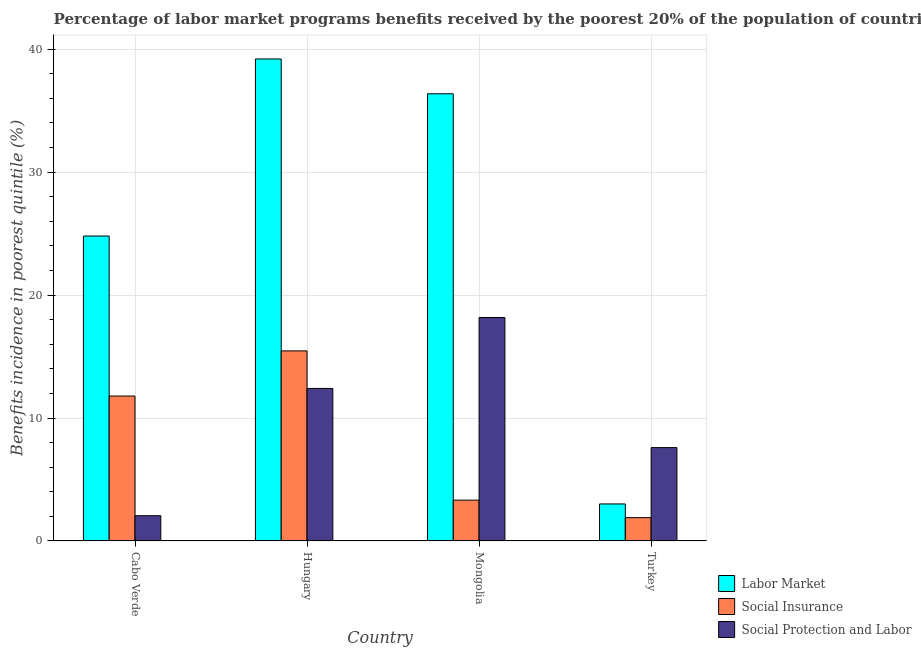Are the number of bars on each tick of the X-axis equal?
Offer a terse response. Yes. How many bars are there on the 4th tick from the right?
Your answer should be compact. 3. In how many cases, is the number of bars for a given country not equal to the number of legend labels?
Make the answer very short. 0. What is the percentage of benefits received due to labor market programs in Cabo Verde?
Provide a short and direct response. 24.8. Across all countries, what is the maximum percentage of benefits received due to social protection programs?
Your answer should be very brief. 18.18. Across all countries, what is the minimum percentage of benefits received due to social insurance programs?
Ensure brevity in your answer.  1.89. In which country was the percentage of benefits received due to social insurance programs maximum?
Make the answer very short. Hungary. In which country was the percentage of benefits received due to social protection programs minimum?
Provide a short and direct response. Cabo Verde. What is the total percentage of benefits received due to labor market programs in the graph?
Your answer should be compact. 103.39. What is the difference between the percentage of benefits received due to social protection programs in Hungary and that in Turkey?
Provide a short and direct response. 4.81. What is the difference between the percentage of benefits received due to social protection programs in Cabo Verde and the percentage of benefits received due to social insurance programs in Mongolia?
Your answer should be compact. -1.27. What is the average percentage of benefits received due to labor market programs per country?
Your answer should be very brief. 25.85. What is the difference between the percentage of benefits received due to social insurance programs and percentage of benefits received due to labor market programs in Hungary?
Offer a very short reply. -23.75. In how many countries, is the percentage of benefits received due to social insurance programs greater than 2 %?
Provide a short and direct response. 3. What is the ratio of the percentage of benefits received due to social insurance programs in Mongolia to that in Turkey?
Ensure brevity in your answer.  1.75. Is the percentage of benefits received due to labor market programs in Hungary less than that in Turkey?
Make the answer very short. No. What is the difference between the highest and the second highest percentage of benefits received due to social protection programs?
Provide a succinct answer. 5.77. What is the difference between the highest and the lowest percentage of benefits received due to social insurance programs?
Offer a very short reply. 13.57. In how many countries, is the percentage of benefits received due to social protection programs greater than the average percentage of benefits received due to social protection programs taken over all countries?
Your answer should be very brief. 2. Is the sum of the percentage of benefits received due to labor market programs in Cabo Verde and Mongolia greater than the maximum percentage of benefits received due to social protection programs across all countries?
Keep it short and to the point. Yes. What does the 3rd bar from the left in Cabo Verde represents?
Provide a succinct answer. Social Protection and Labor. What does the 3rd bar from the right in Mongolia represents?
Offer a very short reply. Labor Market. Is it the case that in every country, the sum of the percentage of benefits received due to labor market programs and percentage of benefits received due to social insurance programs is greater than the percentage of benefits received due to social protection programs?
Provide a short and direct response. No. How many countries are there in the graph?
Your answer should be compact. 4. Are the values on the major ticks of Y-axis written in scientific E-notation?
Ensure brevity in your answer.  No. Where does the legend appear in the graph?
Offer a very short reply. Bottom right. What is the title of the graph?
Provide a short and direct response. Percentage of labor market programs benefits received by the poorest 20% of the population of countries. Does "Transport services" appear as one of the legend labels in the graph?
Your response must be concise. No. What is the label or title of the Y-axis?
Keep it short and to the point. Benefits incidence in poorest quintile (%). What is the Benefits incidence in poorest quintile (%) of Labor Market in Cabo Verde?
Offer a terse response. 24.8. What is the Benefits incidence in poorest quintile (%) in Social Insurance in Cabo Verde?
Make the answer very short. 11.79. What is the Benefits incidence in poorest quintile (%) in Social Protection and Labor in Cabo Verde?
Give a very brief answer. 2.05. What is the Benefits incidence in poorest quintile (%) of Labor Market in Hungary?
Keep it short and to the point. 39.21. What is the Benefits incidence in poorest quintile (%) of Social Insurance in Hungary?
Make the answer very short. 15.46. What is the Benefits incidence in poorest quintile (%) in Social Protection and Labor in Hungary?
Provide a short and direct response. 12.41. What is the Benefits incidence in poorest quintile (%) in Labor Market in Mongolia?
Ensure brevity in your answer.  36.38. What is the Benefits incidence in poorest quintile (%) of Social Insurance in Mongolia?
Offer a very short reply. 3.32. What is the Benefits incidence in poorest quintile (%) of Social Protection and Labor in Mongolia?
Your response must be concise. 18.18. What is the Benefits incidence in poorest quintile (%) in Labor Market in Turkey?
Provide a succinct answer. 3.01. What is the Benefits incidence in poorest quintile (%) of Social Insurance in Turkey?
Your response must be concise. 1.89. What is the Benefits incidence in poorest quintile (%) of Social Protection and Labor in Turkey?
Ensure brevity in your answer.  7.59. Across all countries, what is the maximum Benefits incidence in poorest quintile (%) in Labor Market?
Your answer should be compact. 39.21. Across all countries, what is the maximum Benefits incidence in poorest quintile (%) in Social Insurance?
Your response must be concise. 15.46. Across all countries, what is the maximum Benefits incidence in poorest quintile (%) in Social Protection and Labor?
Provide a short and direct response. 18.18. Across all countries, what is the minimum Benefits incidence in poorest quintile (%) in Labor Market?
Make the answer very short. 3.01. Across all countries, what is the minimum Benefits incidence in poorest quintile (%) of Social Insurance?
Provide a succinct answer. 1.89. Across all countries, what is the minimum Benefits incidence in poorest quintile (%) of Social Protection and Labor?
Keep it short and to the point. 2.05. What is the total Benefits incidence in poorest quintile (%) in Labor Market in the graph?
Provide a succinct answer. 103.39. What is the total Benefits incidence in poorest quintile (%) in Social Insurance in the graph?
Your response must be concise. 32.46. What is the total Benefits incidence in poorest quintile (%) of Social Protection and Labor in the graph?
Provide a short and direct response. 40.23. What is the difference between the Benefits incidence in poorest quintile (%) in Labor Market in Cabo Verde and that in Hungary?
Offer a terse response. -14.4. What is the difference between the Benefits incidence in poorest quintile (%) in Social Insurance in Cabo Verde and that in Hungary?
Your response must be concise. -3.67. What is the difference between the Benefits incidence in poorest quintile (%) in Social Protection and Labor in Cabo Verde and that in Hungary?
Your answer should be very brief. -10.35. What is the difference between the Benefits incidence in poorest quintile (%) in Labor Market in Cabo Verde and that in Mongolia?
Your response must be concise. -11.57. What is the difference between the Benefits incidence in poorest quintile (%) of Social Insurance in Cabo Verde and that in Mongolia?
Your answer should be very brief. 8.47. What is the difference between the Benefits incidence in poorest quintile (%) in Social Protection and Labor in Cabo Verde and that in Mongolia?
Your answer should be very brief. -16.12. What is the difference between the Benefits incidence in poorest quintile (%) of Labor Market in Cabo Verde and that in Turkey?
Your answer should be very brief. 21.79. What is the difference between the Benefits incidence in poorest quintile (%) in Social Insurance in Cabo Verde and that in Turkey?
Your answer should be very brief. 9.89. What is the difference between the Benefits incidence in poorest quintile (%) of Social Protection and Labor in Cabo Verde and that in Turkey?
Offer a terse response. -5.54. What is the difference between the Benefits incidence in poorest quintile (%) of Labor Market in Hungary and that in Mongolia?
Provide a succinct answer. 2.83. What is the difference between the Benefits incidence in poorest quintile (%) in Social Insurance in Hungary and that in Mongolia?
Provide a short and direct response. 12.14. What is the difference between the Benefits incidence in poorest quintile (%) of Social Protection and Labor in Hungary and that in Mongolia?
Your answer should be very brief. -5.77. What is the difference between the Benefits incidence in poorest quintile (%) of Labor Market in Hungary and that in Turkey?
Your answer should be compact. 36.2. What is the difference between the Benefits incidence in poorest quintile (%) in Social Insurance in Hungary and that in Turkey?
Your answer should be compact. 13.57. What is the difference between the Benefits incidence in poorest quintile (%) of Social Protection and Labor in Hungary and that in Turkey?
Offer a terse response. 4.81. What is the difference between the Benefits incidence in poorest quintile (%) of Labor Market in Mongolia and that in Turkey?
Keep it short and to the point. 33.37. What is the difference between the Benefits incidence in poorest quintile (%) in Social Insurance in Mongolia and that in Turkey?
Make the answer very short. 1.42. What is the difference between the Benefits incidence in poorest quintile (%) of Social Protection and Labor in Mongolia and that in Turkey?
Your answer should be very brief. 10.58. What is the difference between the Benefits incidence in poorest quintile (%) of Labor Market in Cabo Verde and the Benefits incidence in poorest quintile (%) of Social Insurance in Hungary?
Give a very brief answer. 9.34. What is the difference between the Benefits incidence in poorest quintile (%) of Labor Market in Cabo Verde and the Benefits incidence in poorest quintile (%) of Social Protection and Labor in Hungary?
Make the answer very short. 12.4. What is the difference between the Benefits incidence in poorest quintile (%) in Social Insurance in Cabo Verde and the Benefits incidence in poorest quintile (%) in Social Protection and Labor in Hungary?
Keep it short and to the point. -0.62. What is the difference between the Benefits incidence in poorest quintile (%) of Labor Market in Cabo Verde and the Benefits incidence in poorest quintile (%) of Social Insurance in Mongolia?
Ensure brevity in your answer.  21.48. What is the difference between the Benefits incidence in poorest quintile (%) in Labor Market in Cabo Verde and the Benefits incidence in poorest quintile (%) in Social Protection and Labor in Mongolia?
Ensure brevity in your answer.  6.63. What is the difference between the Benefits incidence in poorest quintile (%) in Social Insurance in Cabo Verde and the Benefits incidence in poorest quintile (%) in Social Protection and Labor in Mongolia?
Make the answer very short. -6.39. What is the difference between the Benefits incidence in poorest quintile (%) in Labor Market in Cabo Verde and the Benefits incidence in poorest quintile (%) in Social Insurance in Turkey?
Make the answer very short. 22.91. What is the difference between the Benefits incidence in poorest quintile (%) in Labor Market in Cabo Verde and the Benefits incidence in poorest quintile (%) in Social Protection and Labor in Turkey?
Give a very brief answer. 17.21. What is the difference between the Benefits incidence in poorest quintile (%) in Social Insurance in Cabo Verde and the Benefits incidence in poorest quintile (%) in Social Protection and Labor in Turkey?
Offer a terse response. 4.2. What is the difference between the Benefits incidence in poorest quintile (%) of Labor Market in Hungary and the Benefits incidence in poorest quintile (%) of Social Insurance in Mongolia?
Make the answer very short. 35.89. What is the difference between the Benefits incidence in poorest quintile (%) in Labor Market in Hungary and the Benefits incidence in poorest quintile (%) in Social Protection and Labor in Mongolia?
Offer a very short reply. 21.03. What is the difference between the Benefits incidence in poorest quintile (%) of Social Insurance in Hungary and the Benefits incidence in poorest quintile (%) of Social Protection and Labor in Mongolia?
Give a very brief answer. -2.72. What is the difference between the Benefits incidence in poorest quintile (%) in Labor Market in Hungary and the Benefits incidence in poorest quintile (%) in Social Insurance in Turkey?
Keep it short and to the point. 37.31. What is the difference between the Benefits incidence in poorest quintile (%) in Labor Market in Hungary and the Benefits incidence in poorest quintile (%) in Social Protection and Labor in Turkey?
Your answer should be compact. 31.62. What is the difference between the Benefits incidence in poorest quintile (%) in Social Insurance in Hungary and the Benefits incidence in poorest quintile (%) in Social Protection and Labor in Turkey?
Ensure brevity in your answer.  7.87. What is the difference between the Benefits incidence in poorest quintile (%) in Labor Market in Mongolia and the Benefits incidence in poorest quintile (%) in Social Insurance in Turkey?
Keep it short and to the point. 34.48. What is the difference between the Benefits incidence in poorest quintile (%) of Labor Market in Mongolia and the Benefits incidence in poorest quintile (%) of Social Protection and Labor in Turkey?
Your answer should be very brief. 28.78. What is the difference between the Benefits incidence in poorest quintile (%) in Social Insurance in Mongolia and the Benefits incidence in poorest quintile (%) in Social Protection and Labor in Turkey?
Offer a terse response. -4.27. What is the average Benefits incidence in poorest quintile (%) in Labor Market per country?
Provide a succinct answer. 25.85. What is the average Benefits incidence in poorest quintile (%) of Social Insurance per country?
Offer a very short reply. 8.12. What is the average Benefits incidence in poorest quintile (%) in Social Protection and Labor per country?
Offer a very short reply. 10.06. What is the difference between the Benefits incidence in poorest quintile (%) of Labor Market and Benefits incidence in poorest quintile (%) of Social Insurance in Cabo Verde?
Offer a very short reply. 13.02. What is the difference between the Benefits incidence in poorest quintile (%) in Labor Market and Benefits incidence in poorest quintile (%) in Social Protection and Labor in Cabo Verde?
Keep it short and to the point. 22.75. What is the difference between the Benefits incidence in poorest quintile (%) in Social Insurance and Benefits incidence in poorest quintile (%) in Social Protection and Labor in Cabo Verde?
Provide a short and direct response. 9.73. What is the difference between the Benefits incidence in poorest quintile (%) in Labor Market and Benefits incidence in poorest quintile (%) in Social Insurance in Hungary?
Your response must be concise. 23.75. What is the difference between the Benefits incidence in poorest quintile (%) of Labor Market and Benefits incidence in poorest quintile (%) of Social Protection and Labor in Hungary?
Your response must be concise. 26.8. What is the difference between the Benefits incidence in poorest quintile (%) in Social Insurance and Benefits incidence in poorest quintile (%) in Social Protection and Labor in Hungary?
Give a very brief answer. 3.05. What is the difference between the Benefits incidence in poorest quintile (%) of Labor Market and Benefits incidence in poorest quintile (%) of Social Insurance in Mongolia?
Offer a very short reply. 33.06. What is the difference between the Benefits incidence in poorest quintile (%) in Labor Market and Benefits incidence in poorest quintile (%) in Social Protection and Labor in Mongolia?
Make the answer very short. 18.2. What is the difference between the Benefits incidence in poorest quintile (%) in Social Insurance and Benefits incidence in poorest quintile (%) in Social Protection and Labor in Mongolia?
Your response must be concise. -14.86. What is the difference between the Benefits incidence in poorest quintile (%) of Labor Market and Benefits incidence in poorest quintile (%) of Social Insurance in Turkey?
Offer a terse response. 1.11. What is the difference between the Benefits incidence in poorest quintile (%) in Labor Market and Benefits incidence in poorest quintile (%) in Social Protection and Labor in Turkey?
Provide a short and direct response. -4.58. What is the difference between the Benefits incidence in poorest quintile (%) of Social Insurance and Benefits incidence in poorest quintile (%) of Social Protection and Labor in Turkey?
Provide a succinct answer. -5.7. What is the ratio of the Benefits incidence in poorest quintile (%) of Labor Market in Cabo Verde to that in Hungary?
Keep it short and to the point. 0.63. What is the ratio of the Benefits incidence in poorest quintile (%) of Social Insurance in Cabo Verde to that in Hungary?
Your answer should be very brief. 0.76. What is the ratio of the Benefits incidence in poorest quintile (%) in Social Protection and Labor in Cabo Verde to that in Hungary?
Offer a terse response. 0.17. What is the ratio of the Benefits incidence in poorest quintile (%) of Labor Market in Cabo Verde to that in Mongolia?
Your answer should be compact. 0.68. What is the ratio of the Benefits incidence in poorest quintile (%) of Social Insurance in Cabo Verde to that in Mongolia?
Offer a very short reply. 3.55. What is the ratio of the Benefits incidence in poorest quintile (%) of Social Protection and Labor in Cabo Verde to that in Mongolia?
Provide a succinct answer. 0.11. What is the ratio of the Benefits incidence in poorest quintile (%) of Labor Market in Cabo Verde to that in Turkey?
Provide a succinct answer. 8.25. What is the ratio of the Benefits incidence in poorest quintile (%) in Social Insurance in Cabo Verde to that in Turkey?
Keep it short and to the point. 6.22. What is the ratio of the Benefits incidence in poorest quintile (%) in Social Protection and Labor in Cabo Verde to that in Turkey?
Your response must be concise. 0.27. What is the ratio of the Benefits incidence in poorest quintile (%) of Labor Market in Hungary to that in Mongolia?
Give a very brief answer. 1.08. What is the ratio of the Benefits incidence in poorest quintile (%) in Social Insurance in Hungary to that in Mongolia?
Offer a very short reply. 4.66. What is the ratio of the Benefits incidence in poorest quintile (%) in Social Protection and Labor in Hungary to that in Mongolia?
Provide a succinct answer. 0.68. What is the ratio of the Benefits incidence in poorest quintile (%) of Labor Market in Hungary to that in Turkey?
Your answer should be compact. 13.03. What is the ratio of the Benefits incidence in poorest quintile (%) in Social Insurance in Hungary to that in Turkey?
Your answer should be very brief. 8.16. What is the ratio of the Benefits incidence in poorest quintile (%) in Social Protection and Labor in Hungary to that in Turkey?
Keep it short and to the point. 1.63. What is the ratio of the Benefits incidence in poorest quintile (%) of Labor Market in Mongolia to that in Turkey?
Make the answer very short. 12.09. What is the ratio of the Benefits incidence in poorest quintile (%) of Social Insurance in Mongolia to that in Turkey?
Provide a short and direct response. 1.75. What is the ratio of the Benefits incidence in poorest quintile (%) in Social Protection and Labor in Mongolia to that in Turkey?
Offer a very short reply. 2.39. What is the difference between the highest and the second highest Benefits incidence in poorest quintile (%) of Labor Market?
Give a very brief answer. 2.83. What is the difference between the highest and the second highest Benefits incidence in poorest quintile (%) in Social Insurance?
Your response must be concise. 3.67. What is the difference between the highest and the second highest Benefits incidence in poorest quintile (%) of Social Protection and Labor?
Make the answer very short. 5.77. What is the difference between the highest and the lowest Benefits incidence in poorest quintile (%) in Labor Market?
Your response must be concise. 36.2. What is the difference between the highest and the lowest Benefits incidence in poorest quintile (%) of Social Insurance?
Your response must be concise. 13.57. What is the difference between the highest and the lowest Benefits incidence in poorest quintile (%) of Social Protection and Labor?
Offer a terse response. 16.12. 